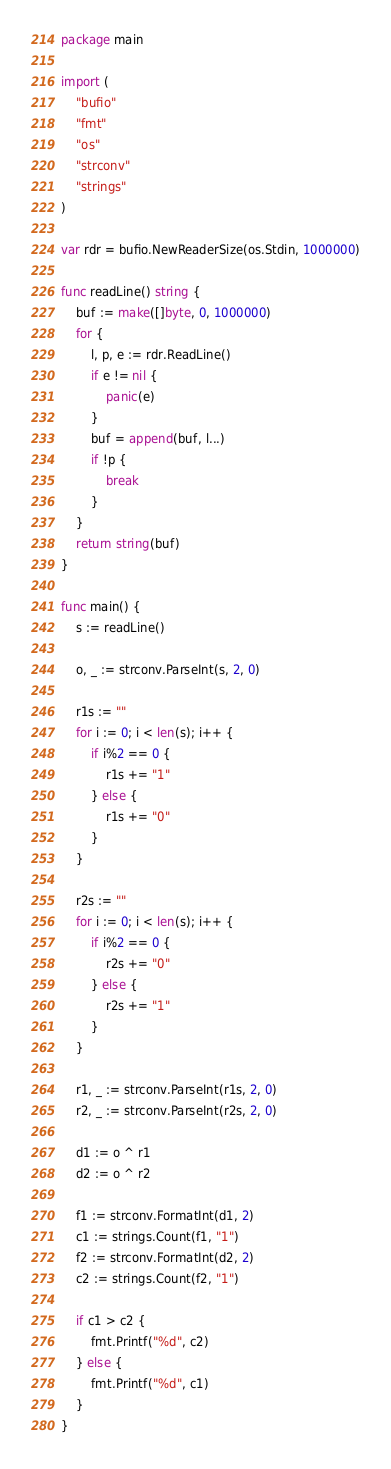Convert code to text. <code><loc_0><loc_0><loc_500><loc_500><_Go_>package main

import (
	"bufio"
	"fmt"
	"os"
	"strconv"
	"strings"
)

var rdr = bufio.NewReaderSize(os.Stdin, 1000000)

func readLine() string {
	buf := make([]byte, 0, 1000000)
	for {
		l, p, e := rdr.ReadLine()
		if e != nil {
			panic(e)
		}
		buf = append(buf, l...)
		if !p {
			break
		}
	}
	return string(buf)
}

func main() {
	s := readLine()

	o, _ := strconv.ParseInt(s, 2, 0)

	r1s := ""
	for i := 0; i < len(s); i++ {
		if i%2 == 0 {
			r1s += "1"
		} else {
			r1s += "0"
		}
	}

	r2s := ""
	for i := 0; i < len(s); i++ {
		if i%2 == 0 {
			r2s += "0"
		} else {
			r2s += "1"
		}
	}

	r1, _ := strconv.ParseInt(r1s, 2, 0)
	r2, _ := strconv.ParseInt(r2s, 2, 0)

	d1 := o ^ r1
	d2 := o ^ r2

	f1 := strconv.FormatInt(d1, 2)
	c1 := strings.Count(f1, "1")
	f2 := strconv.FormatInt(d2, 2)
	c2 := strings.Count(f2, "1")

	if c1 > c2 {
		fmt.Printf("%d", c2)
	} else {
		fmt.Printf("%d", c1)
	}
}
</code> 